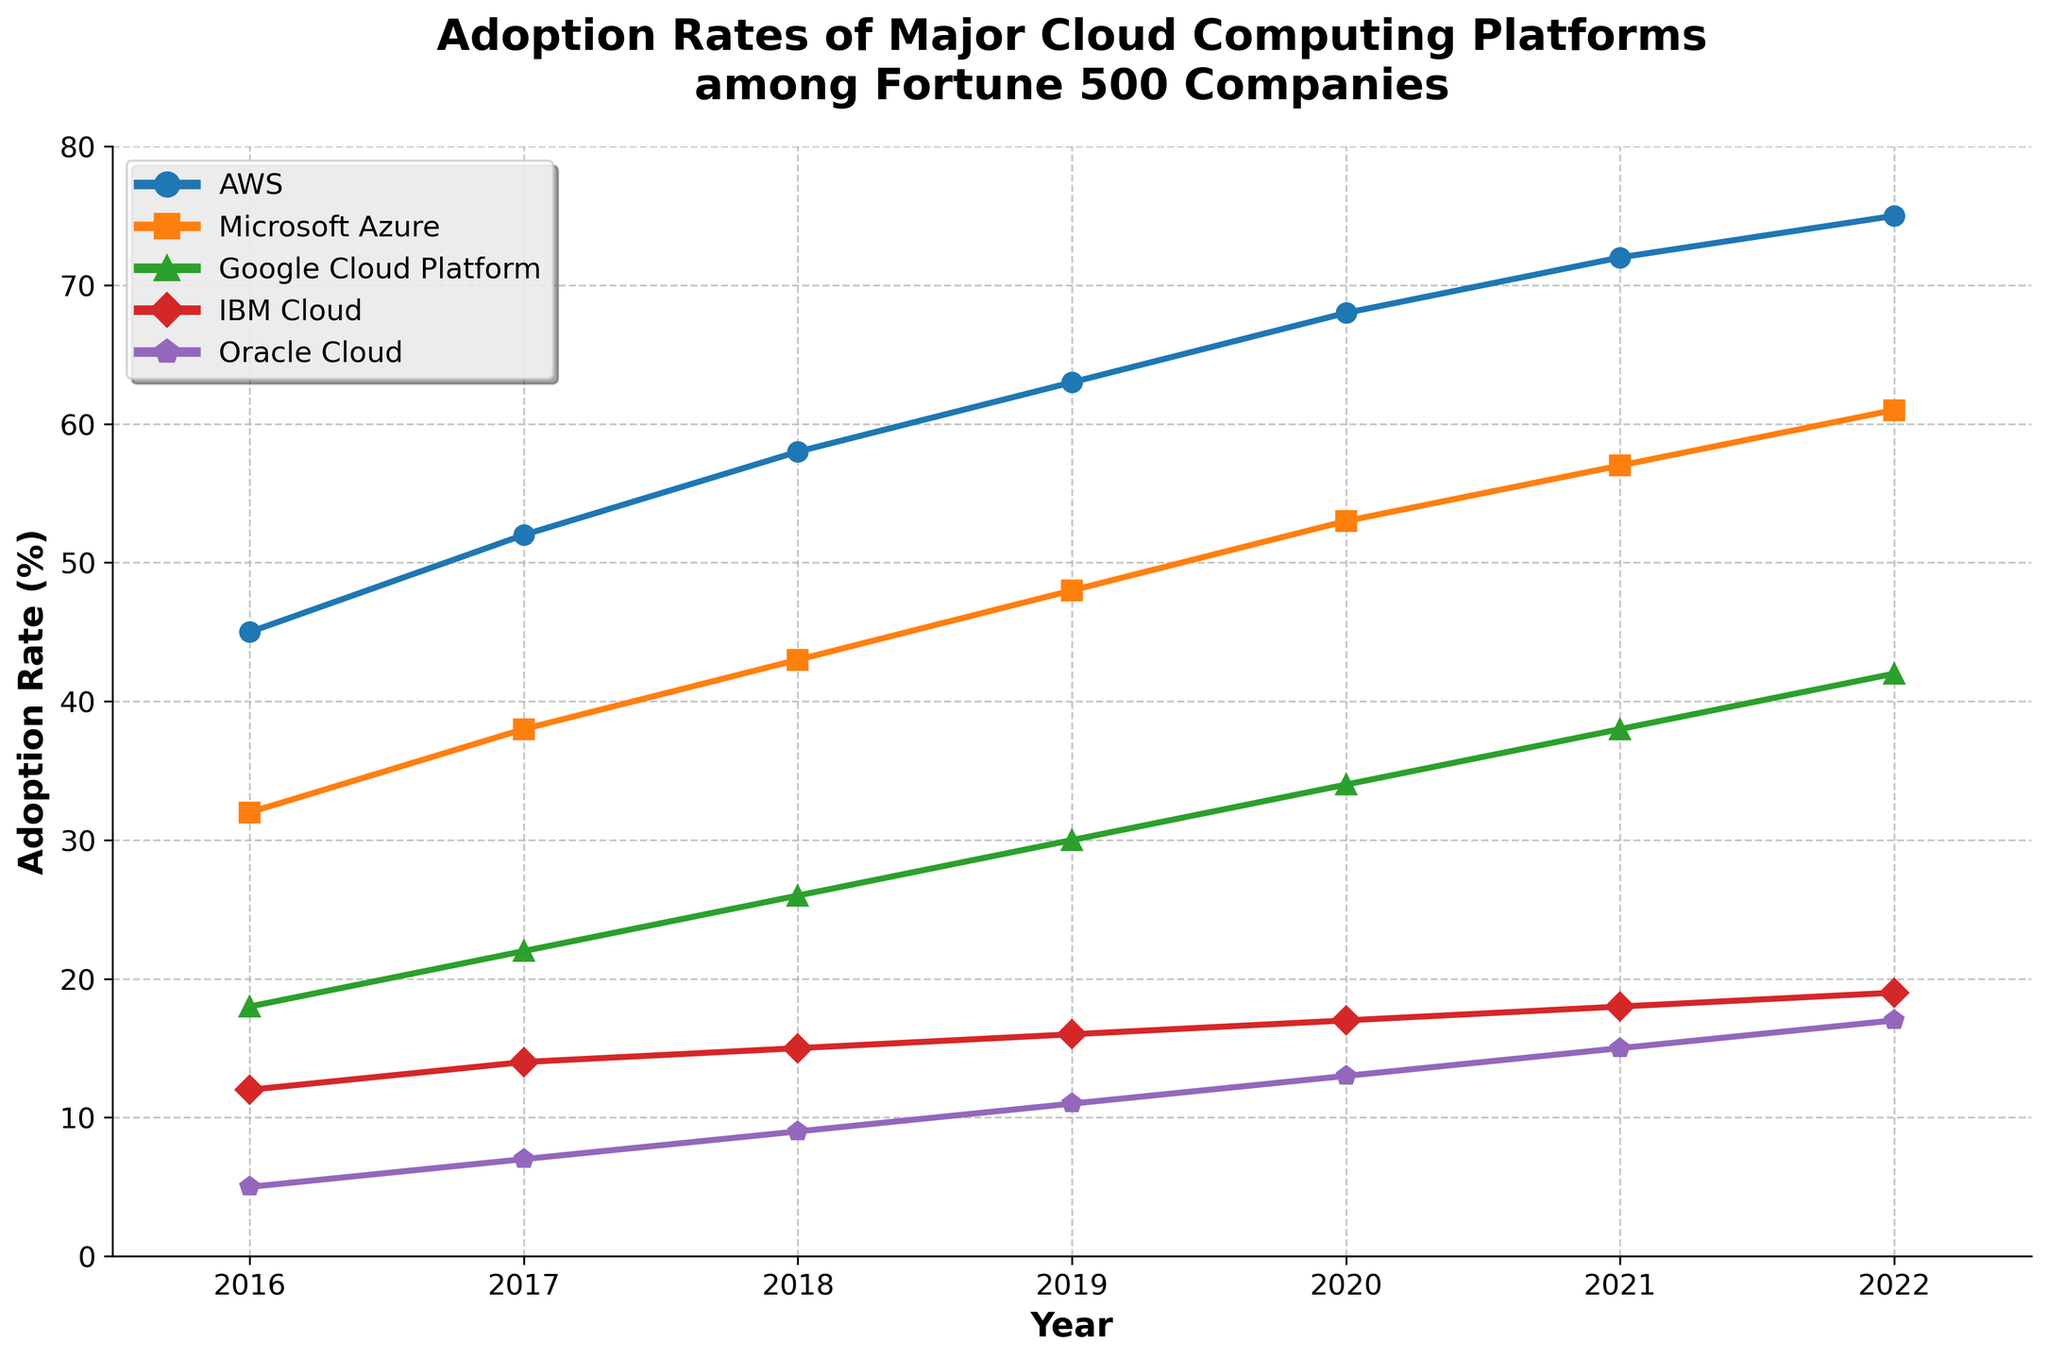What's the trend of AWS adoption rates from 2016 to 2022? To identify the trend in the AWS adoption rates, observe the line corresponding to AWS from 2016 to 2022. Note that the line consistently rises from 45% in 2016 to 75% in 2022.
Answer: Increasing Between Microsoft Azure and Google Cloud Platform, which had a higher adoption rate in 2021? Compare the adoption rates of the lines for Microsoft Azure and Google Cloud Platform in 2021. Microsoft Azure had an adoption rate of 57%, while Google Cloud Platform had 38%. Therefore, Microsoft Azure had a higher adoption rate.
Answer: Microsoft Azure What is the difference in adoption rates between IBM Cloud and Oracle Cloud in 2020? Check the adoption rates for IBM Cloud and Oracle Cloud in 2020. IBM Cloud had 17%, and Oracle Cloud had 13%. Subtract Oracle Cloud's rate from IBM Cloud's rate: 17% - 13% = 4%.
Answer: 4% Which platform had the highest adoption rate in 2019, and what was the rate? Identify the highest point among the lines in 2019. AWS had the highest adoption rate at 63%.
Answer: AWS, 63% What is the average adoption rate of Google Cloud Platform from 2016 to 2022? To find the average adoption rate of Google Cloud Platform over the years, sum the rates from 2016 to 2022 (18 + 22 + 26 + 30 + 34 + 38 + 42) and divide by the number of years (7). The sum is 210, so the average is 210 / 7 ≈ 30.
Answer: 30% By how much did the adoption rate of Oracle Cloud increase from 2016 to 2022? Look at the adoption rates of Oracle Cloud in 2016 (5%) and 2022 (17%). Subtract the former from the latter: 17% - 5% = 12%.
Answer: 12% Which platform experienced the smallest increase in adoption rate from 2016 to 2022? Calculate the increase in adoption rates for each platform between 2016 and 2022. AWS increased by 75 - 45 = 30%, Microsoft Azure by 61 - 32 = 29%, Google Cloud Platform by 42 - 18 = 24%, IBM Cloud by 19 - 12 = 7%, and Oracle Cloud by 17 - 5 = 12%. IBM Cloud had the smallest increase.
Answer: IBM Cloud From 2016 to 2017, which platform had the largest increase in its adoption rate? Calculate the increase for each platform from 2016 to 2017. AWS increased by 7%, Microsoft Azure by 6%, Google Cloud Platform by 4%, IBM Cloud by 2%, and Oracle Cloud by 2%. AWS had the largest increase.
Answer: AWS What is the total adoption rate of AWS, Microsoft Azure, and Google Cloud Platform in 2020? Sum the adoption rates of AWS, Microsoft Azure, and Google Cloud Platform for 2020. The rates are AWS (68%), Microsoft Azure (53%), and Google Cloud Platform (34%). The total is 68 + 53 + 34 = 155%.
Answer: 155% Which platform had the second-lowest adoption rate in 2018? Identify the platforms' adoption rates in 2018. The rates are AWS (58%), Microsoft Azure (43%), Google Cloud Platform (26%), IBM Cloud (15%), and Oracle Cloud (9%). The second-lowest rate is IBM Cloud at 15%.
Answer: IBM Cloud 